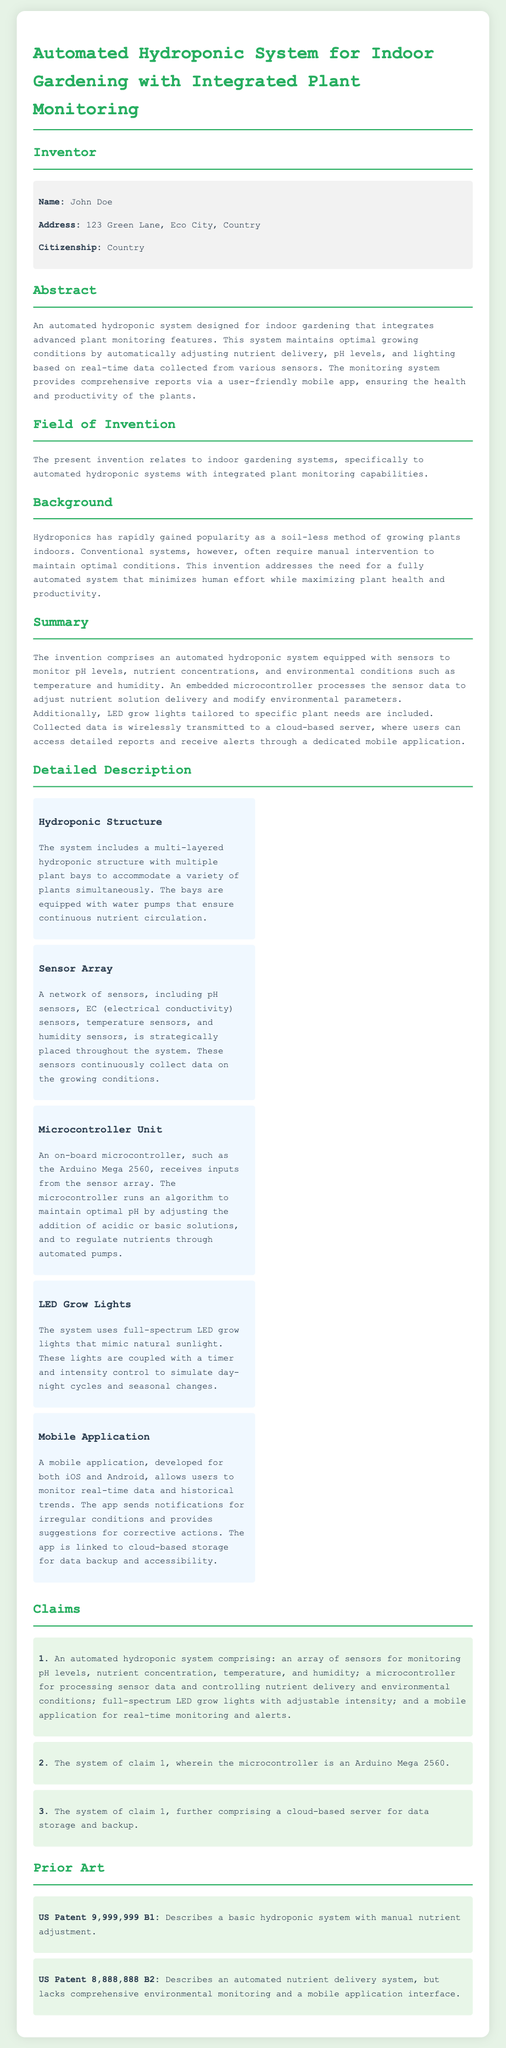What is the name of the inventor? The document provides the name of the inventor in the inventors section as John Doe.
Answer: John Doe What type of system does the patent application detail? The abstract indicates the system is an automated hydroponic system designed for indoor gardening.
Answer: Automated hydroponic system What is the purpose of the mobile application? The summary states that the mobile application provides real-time monitoring and alerts for plant conditions.
Answer: Real-time monitoring and alerts Which microcontroller is mentioned in the document? The detailed description identifies the microcontroller as an Arduino Mega 2560.
Answer: Arduino Mega 2560 How many claims are present in the document? The claims section lists three distinct claims related to the invention.
Answer: Three What does the prior art US Patent 9,999,999 B1 describe? The prior art section mentions it describes a basic hydroponic system with manual nutrient adjustment.
Answer: Basic hydroponic system with manual nutrient adjustment What type of sensors are included in the system? The sensor array includes pH sensors, EC sensors, temperature sensors, and humidity sensors as detailed in the document.
Answer: pH sensors, EC sensors, temperature sensors, and humidity sensors What are the LED grow lights designed to mimic? The detailed description explains that the LED grow lights mimic natural sunlight.
Answer: Natural sunlight 